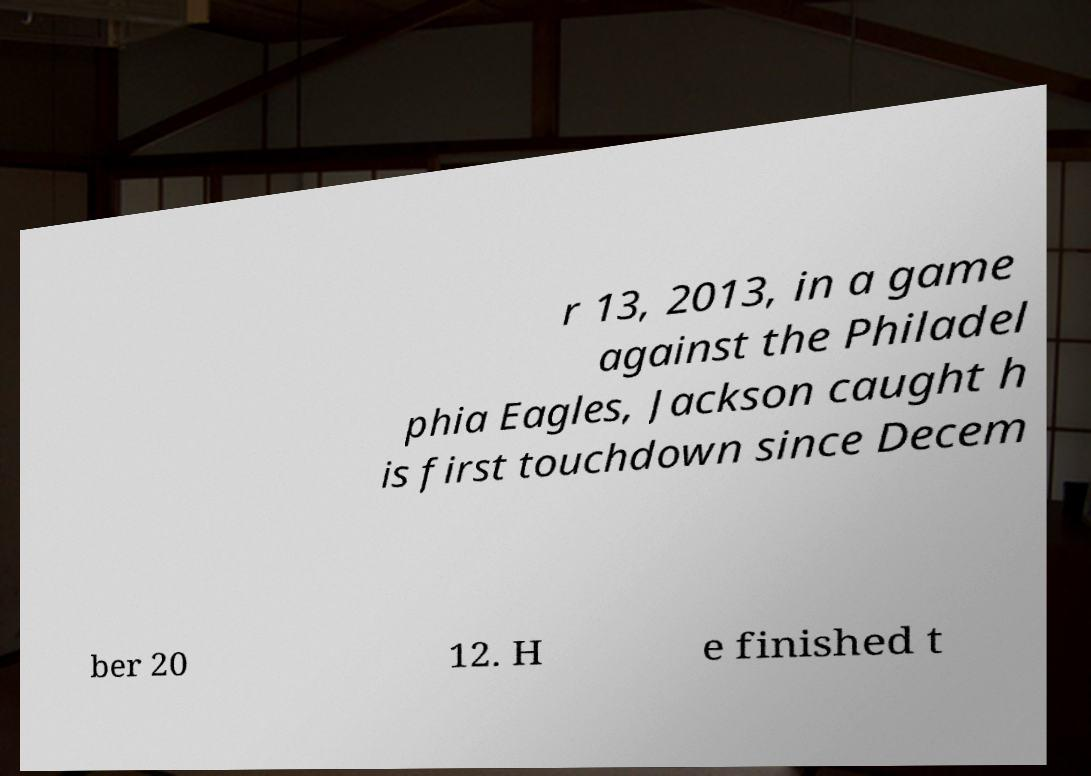Please read and relay the text visible in this image. What does it say? r 13, 2013, in a game against the Philadel phia Eagles, Jackson caught h is first touchdown since Decem ber 20 12. H e finished t 